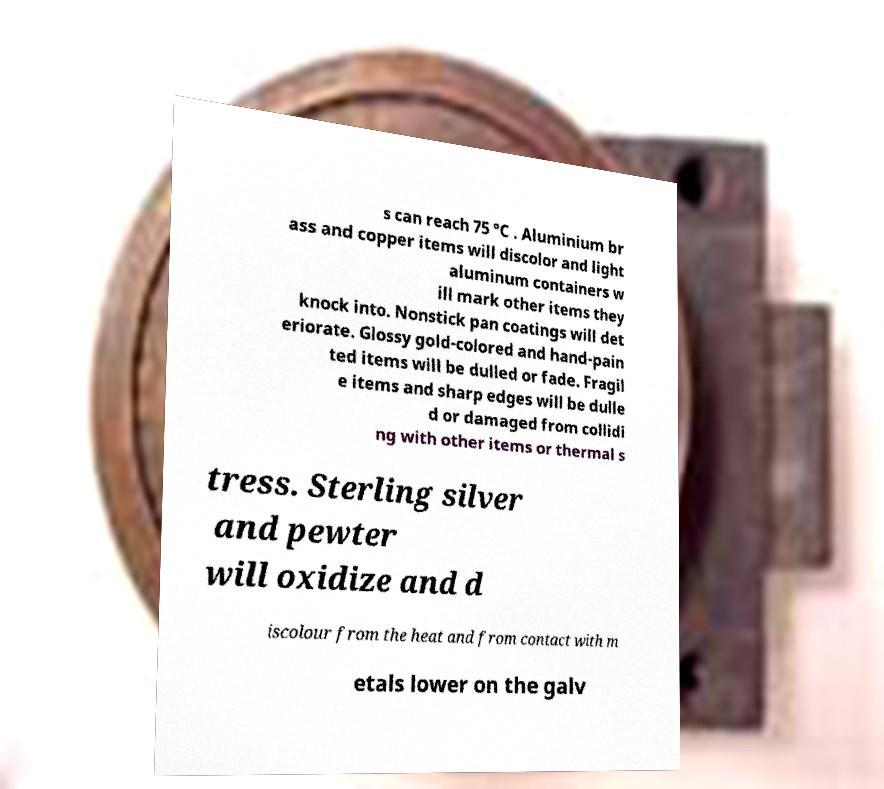What messages or text are displayed in this image? I need them in a readable, typed format. s can reach 75 °C . Aluminium br ass and copper items will discolor and light aluminum containers w ill mark other items they knock into. Nonstick pan coatings will det eriorate. Glossy gold-colored and hand-pain ted items will be dulled or fade. Fragil e items and sharp edges will be dulle d or damaged from collidi ng with other items or thermal s tress. Sterling silver and pewter will oxidize and d iscolour from the heat and from contact with m etals lower on the galv 